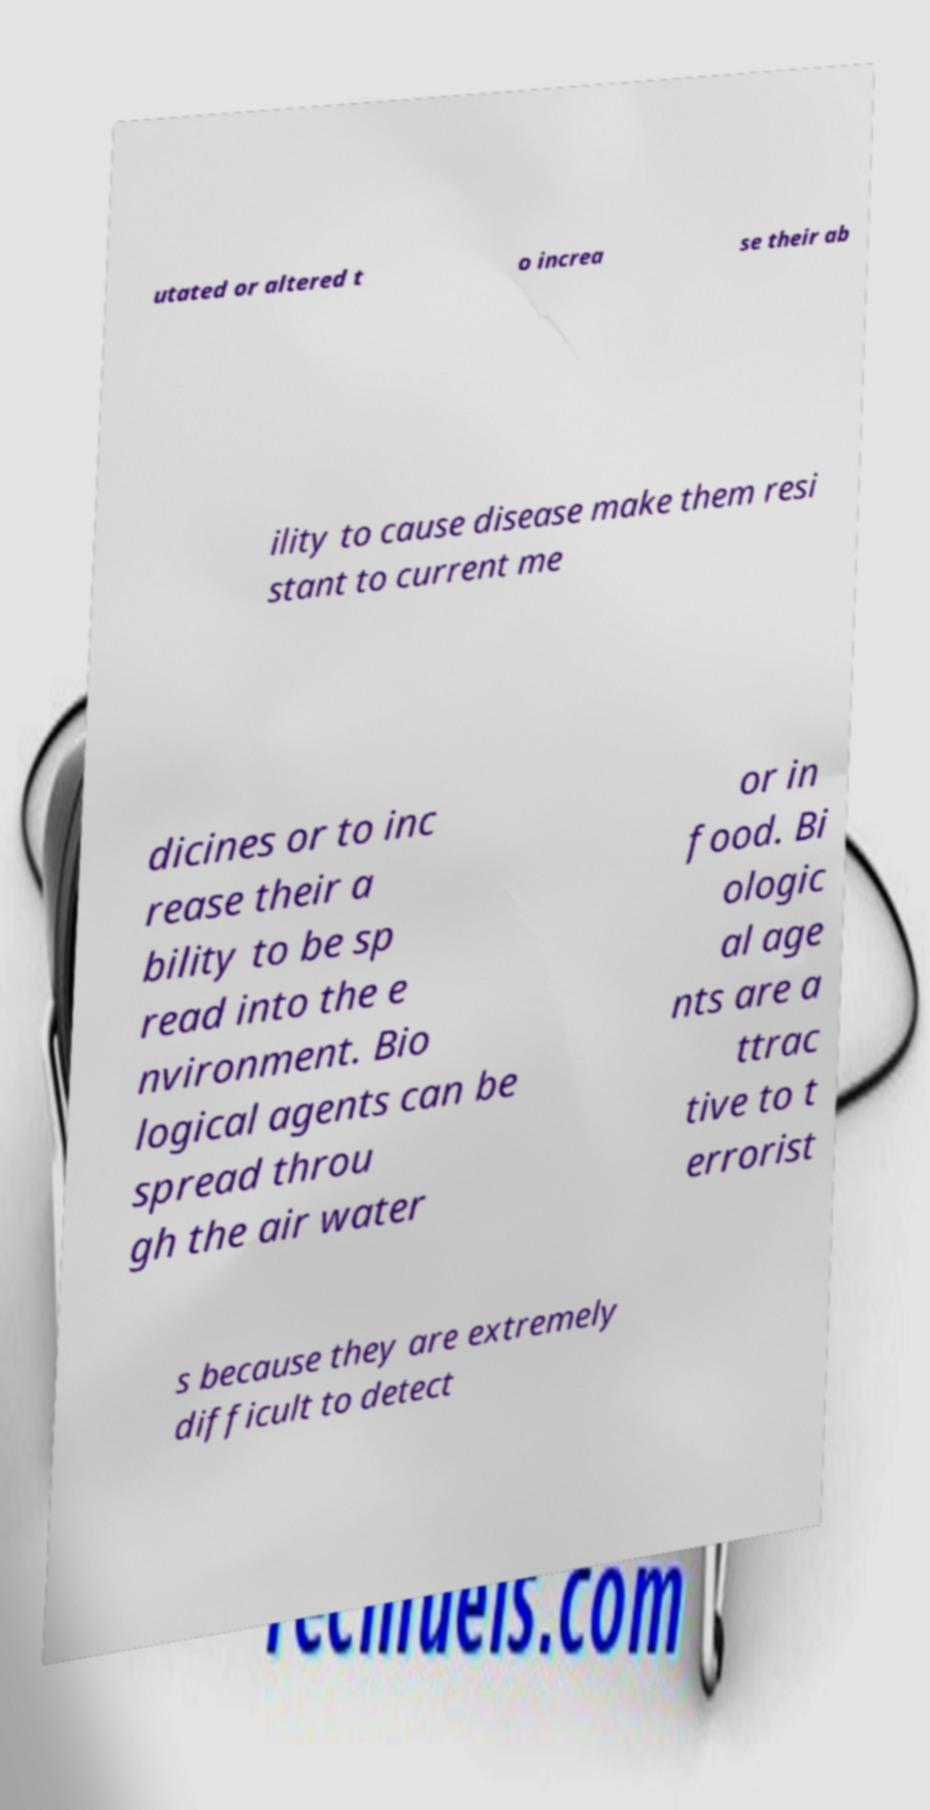Could you extract and type out the text from this image? utated or altered t o increa se their ab ility to cause disease make them resi stant to current me dicines or to inc rease their a bility to be sp read into the e nvironment. Bio logical agents can be spread throu gh the air water or in food. Bi ologic al age nts are a ttrac tive to t errorist s because they are extremely difficult to detect 